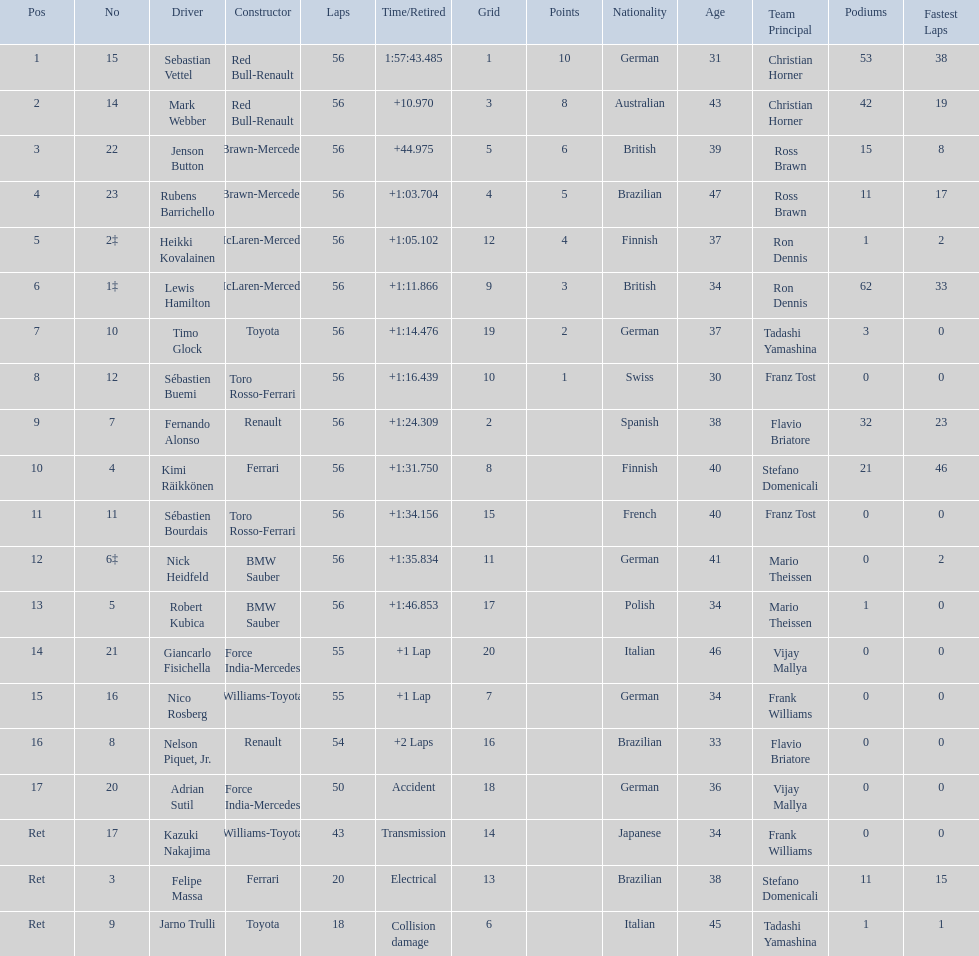Heikki kovalainen and lewis hamilton both had which constructor? McLaren-Mercedes. Give me the full table as a dictionary. {'header': ['Pos', 'No', 'Driver', 'Constructor', 'Laps', 'Time/Retired', 'Grid', 'Points', 'Nationality', 'Age', 'Team Principal', 'Podiums', 'Fastest Laps'], 'rows': [['1', '15', 'Sebastian Vettel', 'Red Bull-Renault', '56', '1:57:43.485', '1', '10', 'German', '31', 'Christian Horner', '53', '38'], ['2', '14', 'Mark Webber', 'Red Bull-Renault', '56', '+10.970', '3', '8', 'Australian', '43', 'Christian Horner', '42', '19'], ['3', '22', 'Jenson Button', 'Brawn-Mercedes', '56', '+44.975', '5', '6', 'British', '39', 'Ross Brawn', '15', '8'], ['4', '23', 'Rubens Barrichello', 'Brawn-Mercedes', '56', '+1:03.704', '4', '5', 'Brazilian', '47', 'Ross Brawn', '11', '17'], ['5', '2‡', 'Heikki Kovalainen', 'McLaren-Mercedes', '56', '+1:05.102', '12', '4', 'Finnish', '37', 'Ron Dennis', '1', '2'], ['6', '1‡', 'Lewis Hamilton', 'McLaren-Mercedes', '56', '+1:11.866', '9', '3', 'British', '34', 'Ron Dennis', '62', '33'], ['7', '10', 'Timo Glock', 'Toyota', '56', '+1:14.476', '19', '2', 'German', '37', 'Tadashi Yamashina', '3', '0'], ['8', '12', 'Sébastien Buemi', 'Toro Rosso-Ferrari', '56', '+1:16.439', '10', '1', 'Swiss', '30', 'Franz Tost', '0', '0'], ['9', '7', 'Fernando Alonso', 'Renault', '56', '+1:24.309', '2', '', 'Spanish', '38', 'Flavio Briatore', '32', '23'], ['10', '4', 'Kimi Räikkönen', 'Ferrari', '56', '+1:31.750', '8', '', 'Finnish', '40', 'Stefano Domenicali', '21', '46'], ['11', '11', 'Sébastien Bourdais', 'Toro Rosso-Ferrari', '56', '+1:34.156', '15', '', 'French', '40', 'Franz Tost', '0', '0'], ['12', '6‡', 'Nick Heidfeld', 'BMW Sauber', '56', '+1:35.834', '11', '', 'German', '41', 'Mario Theissen', '0', '2'], ['13', '5', 'Robert Kubica', 'BMW Sauber', '56', '+1:46.853', '17', '', 'Polish', '34', 'Mario Theissen', '1', '0'], ['14', '21', 'Giancarlo Fisichella', 'Force India-Mercedes', '55', '+1 Lap', '20', '', 'Italian', '46', 'Vijay Mallya', '0', '0'], ['15', '16', 'Nico Rosberg', 'Williams-Toyota', '55', '+1 Lap', '7', '', 'German', '34', 'Frank Williams', '0', '0'], ['16', '8', 'Nelson Piquet, Jr.', 'Renault', '54', '+2 Laps', '16', '', 'Brazilian', '33', 'Flavio Briatore', '0', '0'], ['17', '20', 'Adrian Sutil', 'Force India-Mercedes', '50', 'Accident', '18', '', 'German', '36', 'Vijay Mallya', '0', '0'], ['Ret', '17', 'Kazuki Nakajima', 'Williams-Toyota', '43', 'Transmission', '14', '', 'Japanese', '34', 'Frank Williams', '0', '0'], ['Ret', '3', 'Felipe Massa', 'Ferrari', '20', 'Electrical', '13', '', 'Brazilian', '38', 'Stefano Domenicali', '11', '15'], ['Ret', '9', 'Jarno Trulli', 'Toyota', '18', 'Collision damage', '6', '', 'Italian', '45', 'Tadashi Yamashina', '1', '1']]} 